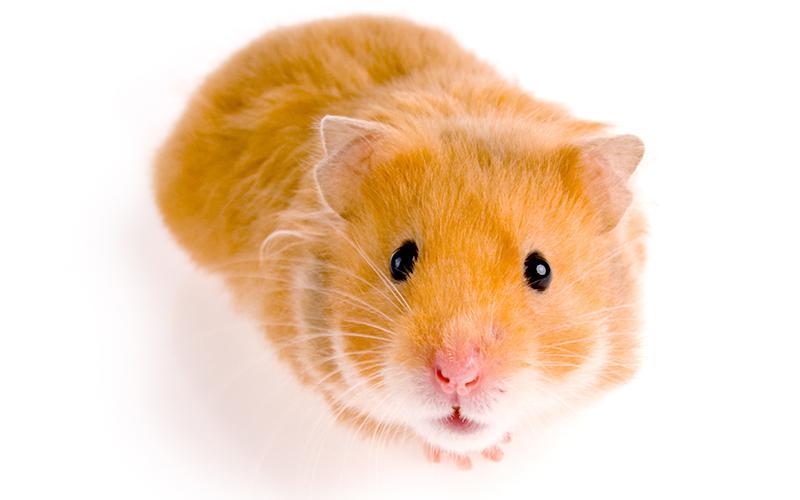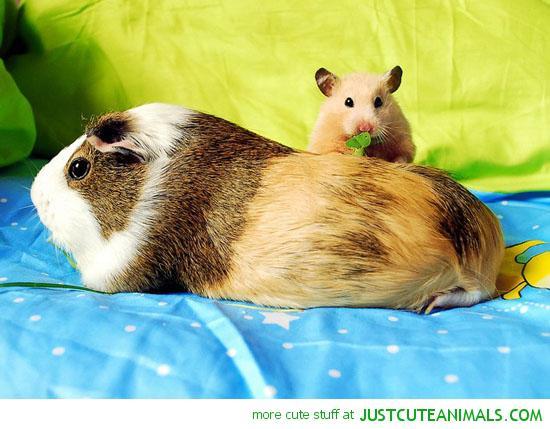The first image is the image on the left, the second image is the image on the right. Evaluate the accuracy of this statement regarding the images: "One of the images features a small animal in between two rabbits, while the other image features at least two guinea pigs.". Is it true? Answer yes or no. No. The first image is the image on the left, the second image is the image on the right. Evaluate the accuracy of this statement regarding the images: "The right image contains two rabbits.". Is it true? Answer yes or no. No. 